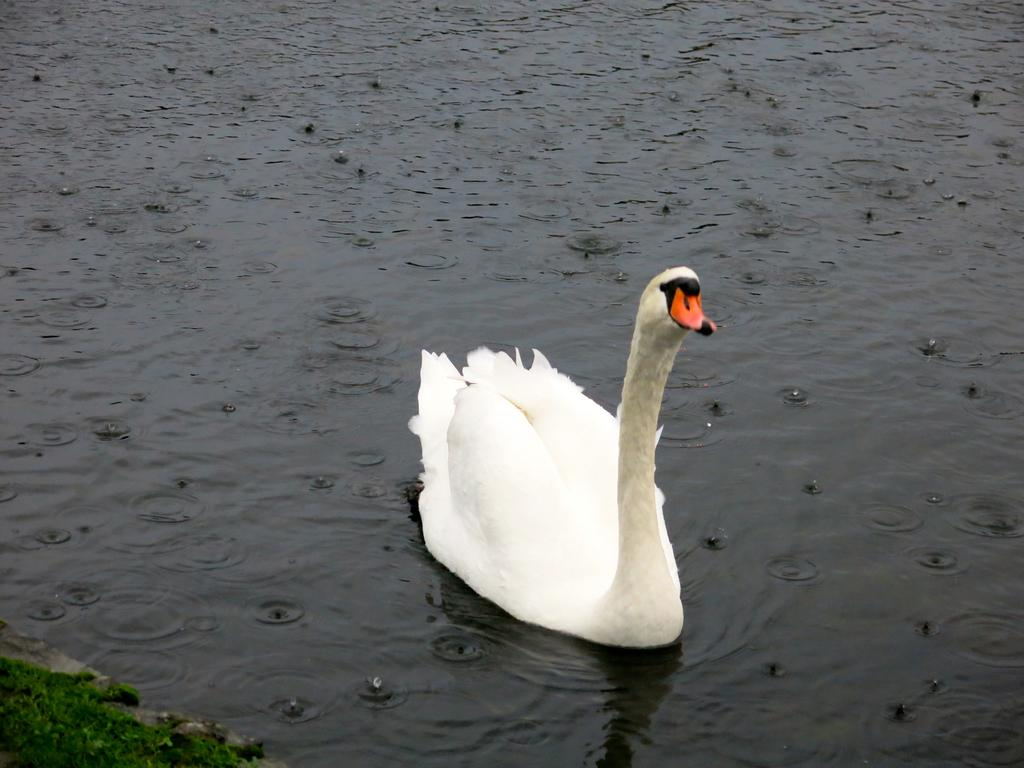What is one of the natural elements present in the image? There is water in the image. What type of vegetation can be seen in the image? There is grass in the image. What kind of animal is visible in the image? There is a white-colored bird in the image. What type of soap is being used by the bird in the image? There is no soap present in the image, and the bird is not using any soap. What sound does the bird make in the image? The image does not provide any information about the sound the bird might make. 